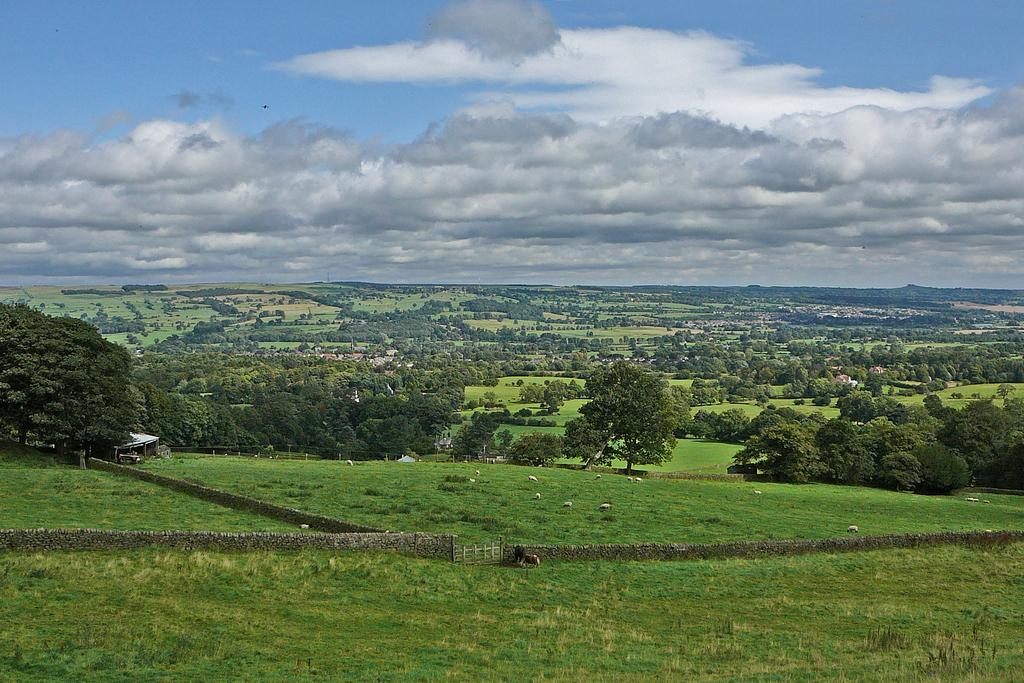What type of living organisms can be seen in the image? There are animals in the image. Where are the animals located? The animals are on the grass on the ground. What architectural feature is present in the image? There is a wall with a gate in the image. What can be seen in the background of the image? Trees and clouds are visible in the blue sky in the background of the image. What color is the scarf that the animals are wearing in the image? There are no scarves present in the image, as the animals are not wearing any clothing. Why do the animals fall from the trees in the image? There are no animals falling from trees in the image; the animals are on the grass on the ground. 